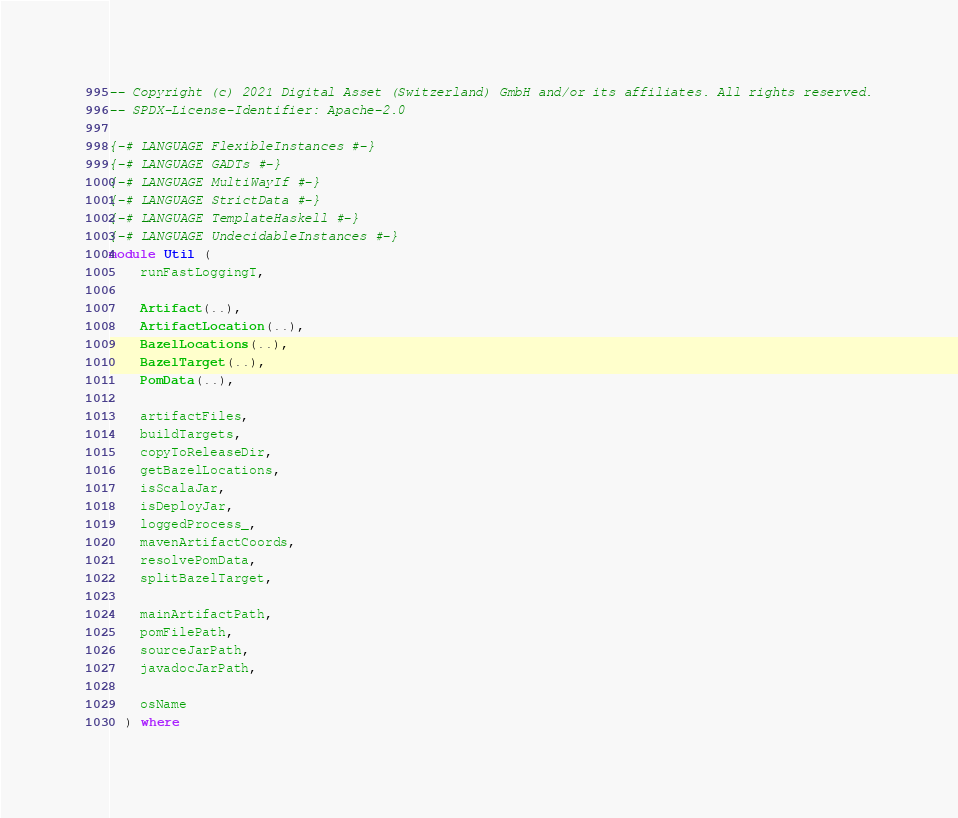Convert code to text. <code><loc_0><loc_0><loc_500><loc_500><_Haskell_>-- Copyright (c) 2021 Digital Asset (Switzerland) GmbH and/or its affiliates. All rights reserved.
-- SPDX-License-Identifier: Apache-2.0

{-# LANGUAGE FlexibleInstances #-}
{-# LANGUAGE GADTs #-}
{-# LANGUAGE MultiWayIf #-}
{-# LANGUAGE StrictData #-}
{-# LANGUAGE TemplateHaskell #-}
{-# LANGUAGE UndecidableInstances #-}
module Util (
    runFastLoggingT,

    Artifact(..),
    ArtifactLocation(..),
    BazelLocations(..),
    BazelTarget(..),
    PomData(..),

    artifactFiles,
    buildTargets,
    copyToReleaseDir,
    getBazelLocations,
    isScalaJar,
    isDeployJar,
    loggedProcess_,
    mavenArtifactCoords,
    resolvePomData,
    splitBazelTarget,

    mainArtifactPath,
    pomFilePath,
    sourceJarPath,
    javadocJarPath,

    osName
  ) where

</code> 